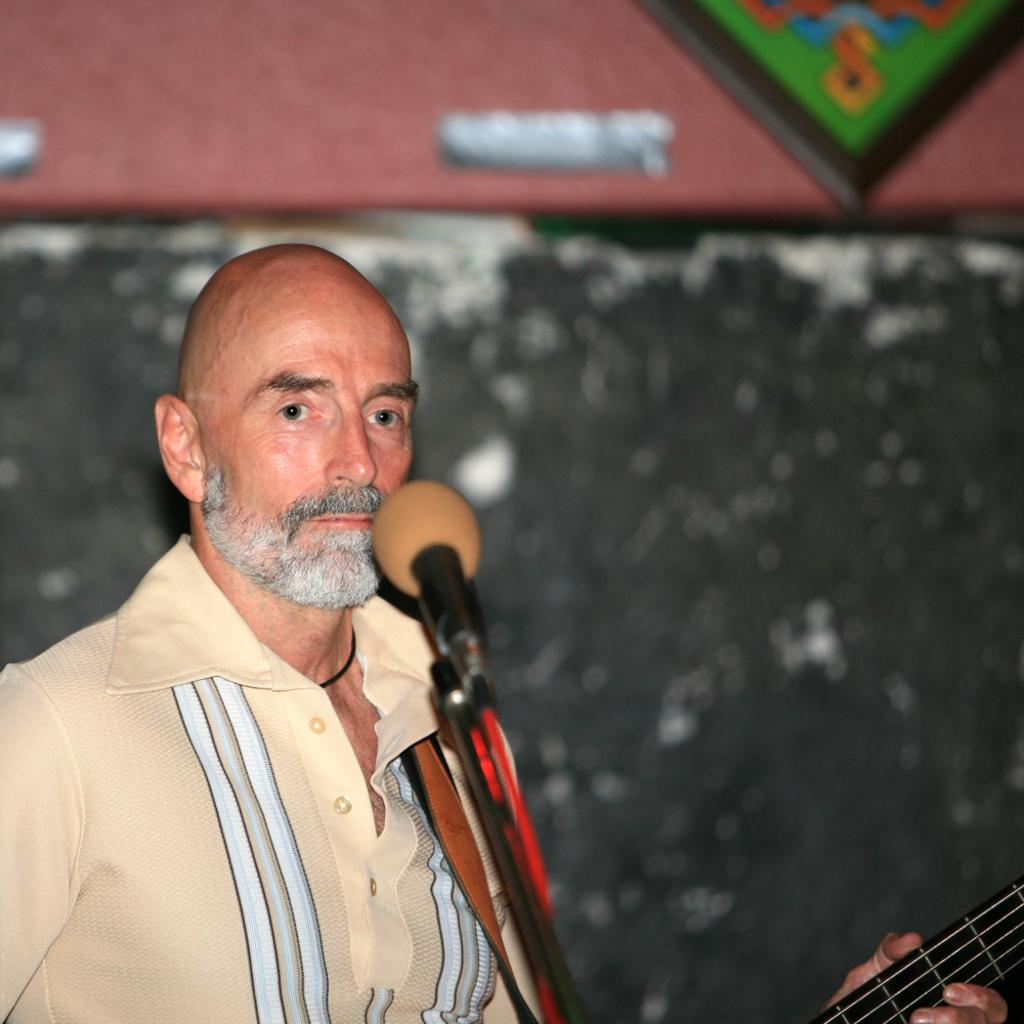Who or what is on the left side of the image? There is a person on the left side of the image. What is the person doing in the image? The person is in front of a microphone. What can be seen behind the person? There is a wall in the background of the image. What instrument might the person be playing? The person appears to be holding a guitar. What type of paint is being used to create the nation in the image? There is no nation or paint present in the image; it features a person with a guitar in front of a microphone. What game is the person playing in the image? There is no game being played in the image; the person is holding a guitar and standing in front of a microphone. 